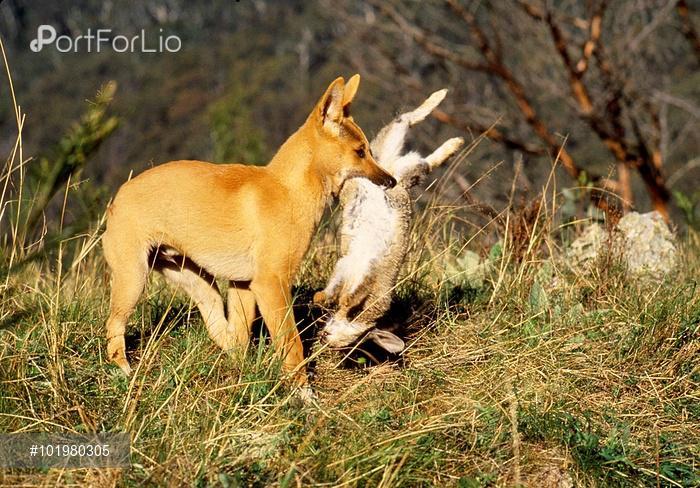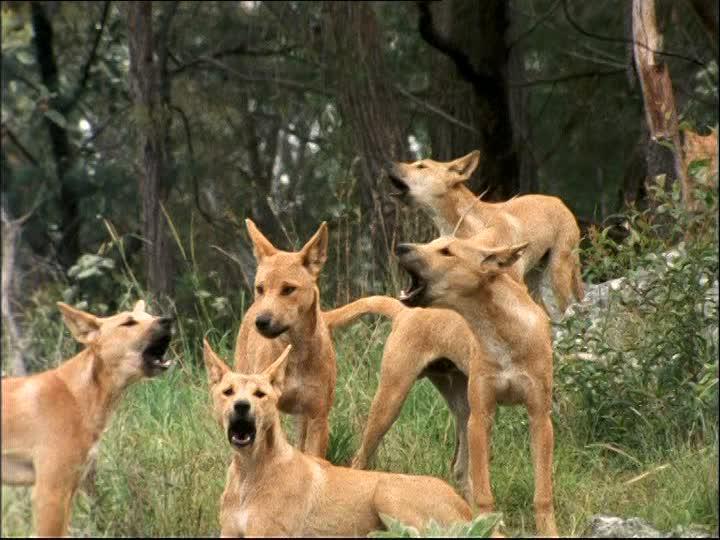The first image is the image on the left, the second image is the image on the right. Assess this claim about the two images: "A total of three canine animals are shown.". Correct or not? Answer yes or no. No. The first image is the image on the left, the second image is the image on the right. Evaluate the accuracy of this statement regarding the images: "There are no less than four animals". Is it true? Answer yes or no. Yes. 